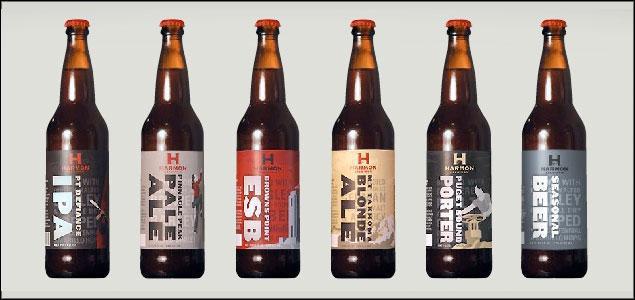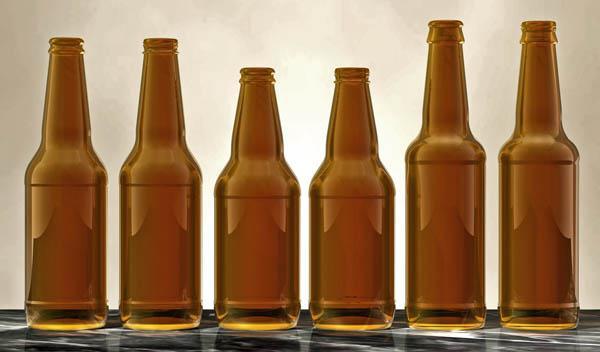The first image is the image on the left, the second image is the image on the right. Examine the images to the left and right. Is the description "There are more than 10 bottles." accurate? Answer yes or no. Yes. The first image is the image on the left, the second image is the image on the right. Given the left and right images, does the statement "There are more than ten bottles in total." hold true? Answer yes or no. Yes. 